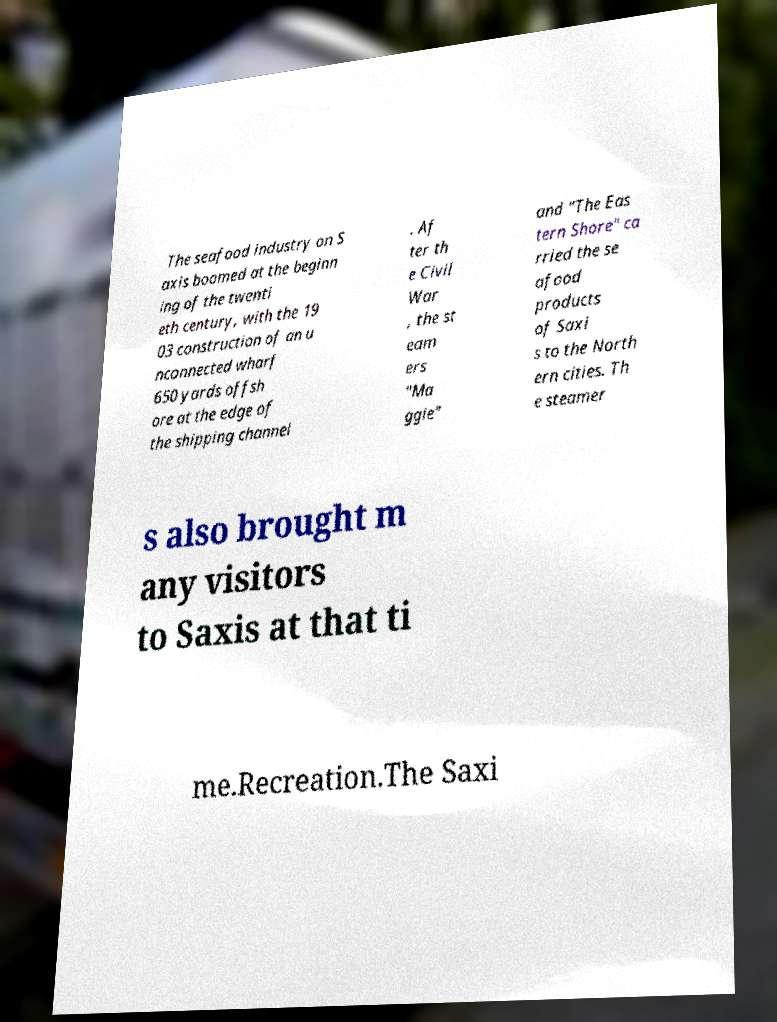Please identify and transcribe the text found in this image. The seafood industry on S axis boomed at the beginn ing of the twenti eth century, with the 19 03 construction of an u nconnected wharf 650 yards offsh ore at the edge of the shipping channel . Af ter th e Civil War , the st eam ers "Ma ggie" and "The Eas tern Shore" ca rried the se afood products of Saxi s to the North ern cities. Th e steamer s also brought m any visitors to Saxis at that ti me.Recreation.The Saxi 